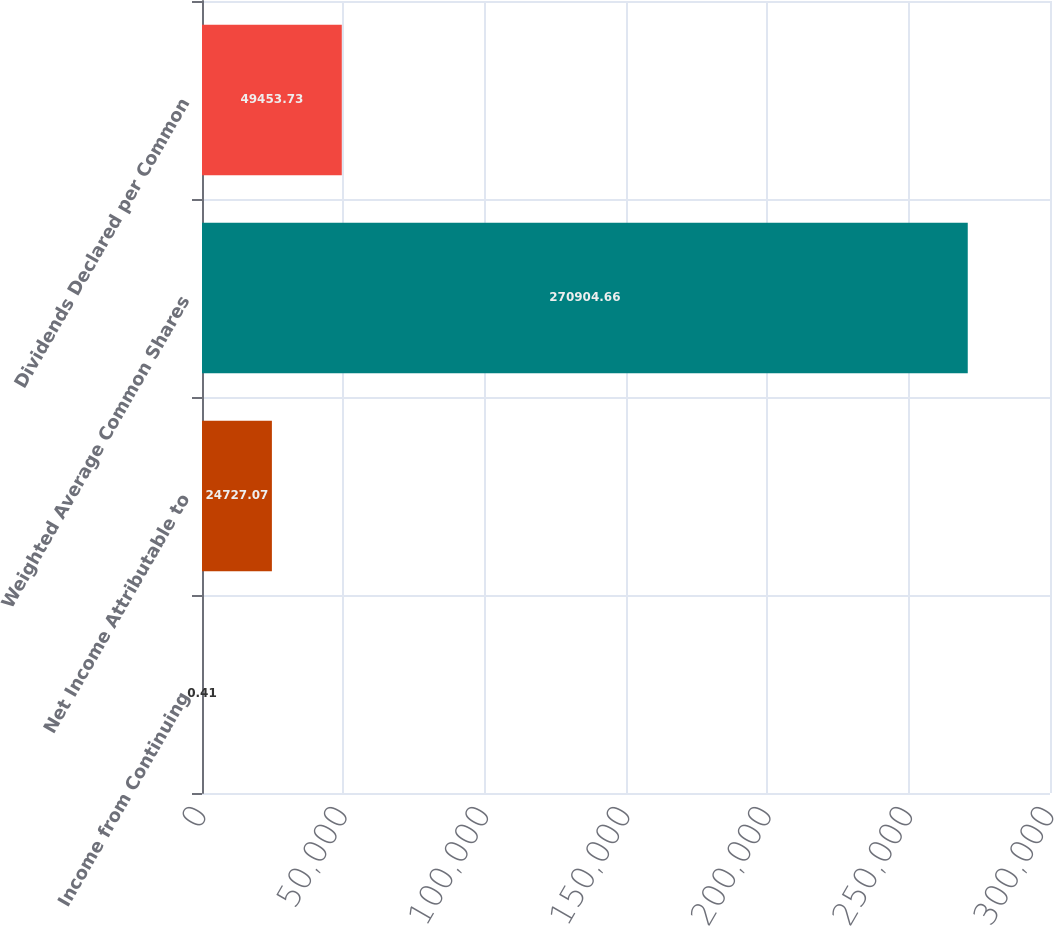<chart> <loc_0><loc_0><loc_500><loc_500><bar_chart><fcel>Income from Continuing<fcel>Net Income Attributable to<fcel>Weighted Average Common Shares<fcel>Dividends Declared per Common<nl><fcel>0.41<fcel>24727.1<fcel>270905<fcel>49453.7<nl></chart> 